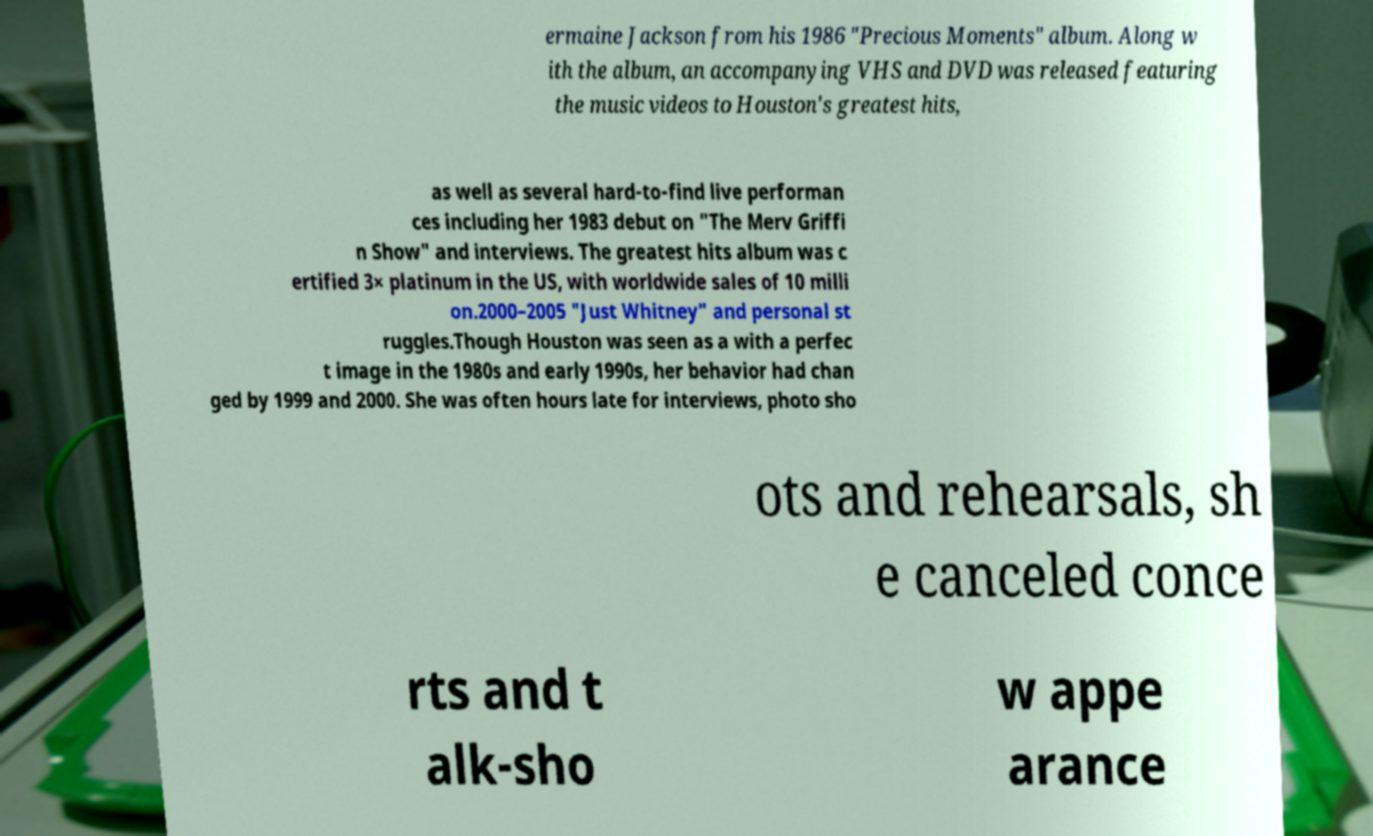What messages or text are displayed in this image? I need them in a readable, typed format. ermaine Jackson from his 1986 "Precious Moments" album. Along w ith the album, an accompanying VHS and DVD was released featuring the music videos to Houston's greatest hits, as well as several hard-to-find live performan ces including her 1983 debut on "The Merv Griffi n Show" and interviews. The greatest hits album was c ertified 3× platinum in the US, with worldwide sales of 10 milli on.2000–2005 "Just Whitney" and personal st ruggles.Though Houston was seen as a with a perfec t image in the 1980s and early 1990s, her behavior had chan ged by 1999 and 2000. She was often hours late for interviews, photo sho ots and rehearsals, sh e canceled conce rts and t alk-sho w appe arance 